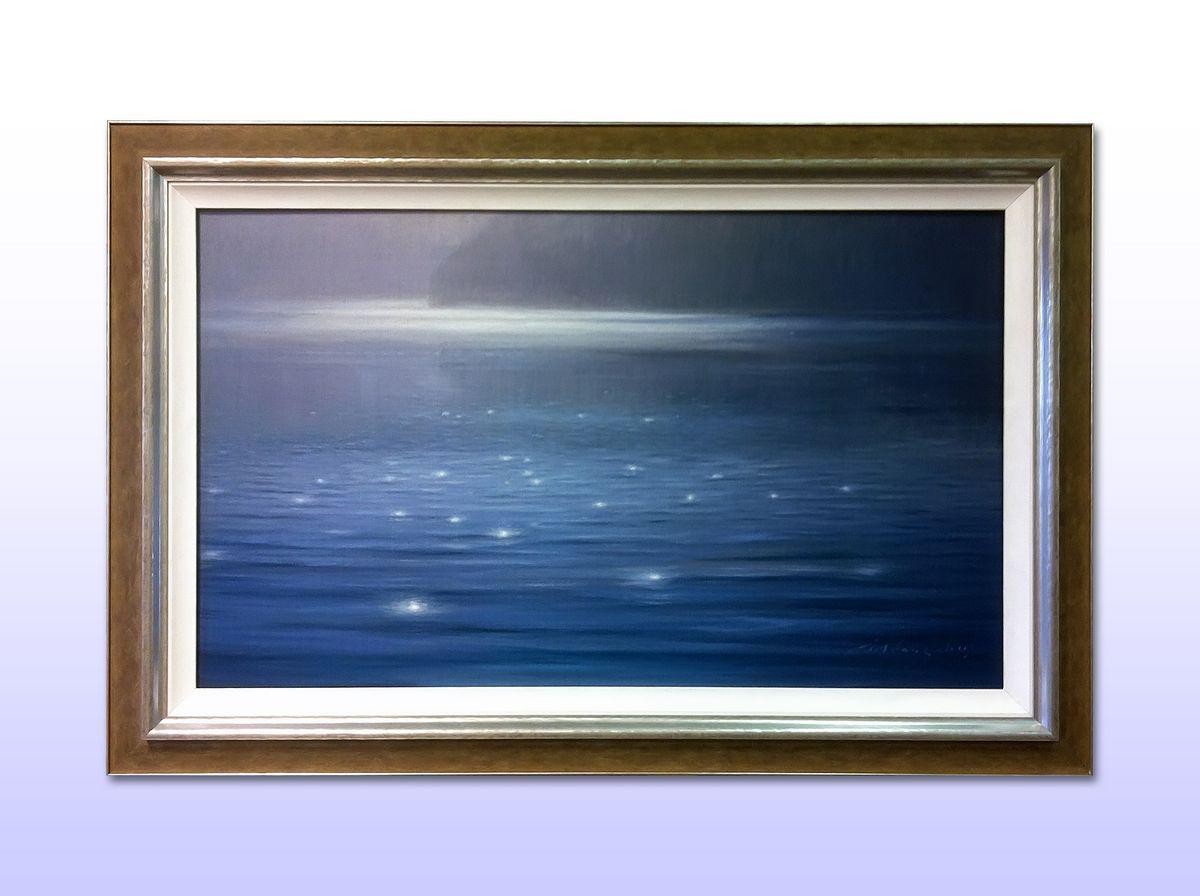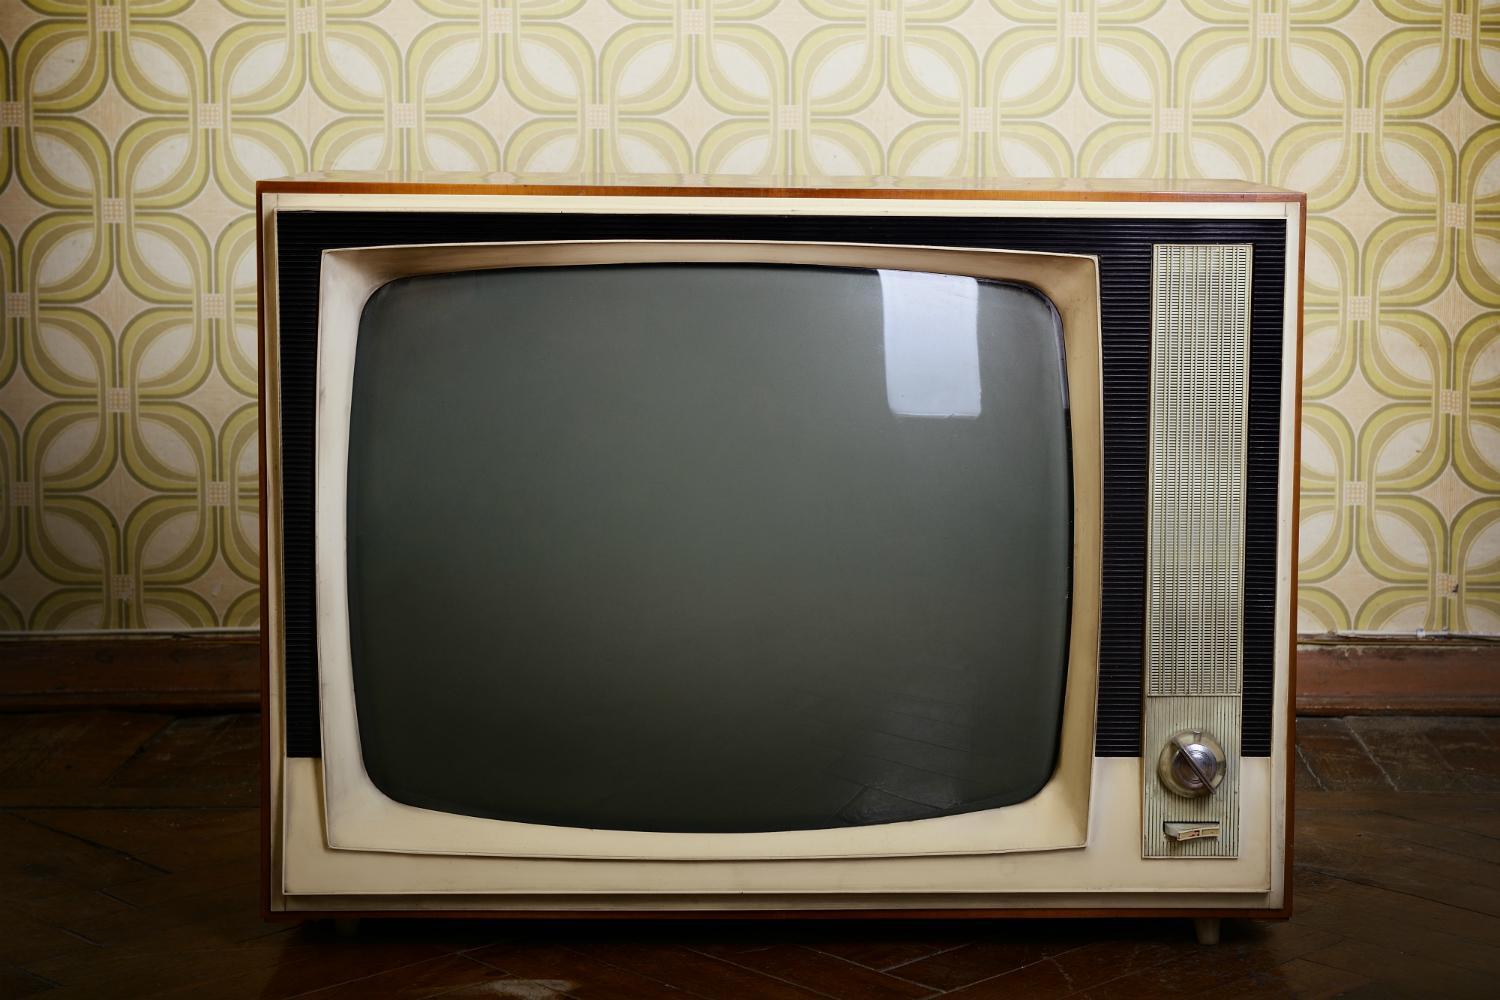The first image is the image on the left, the second image is the image on the right. Considering the images on both sides, is "A portable television has a vertical control area to one side, with two large knobs at the top, and a small speaker area below." valid? Answer yes or no. No. The first image is the image on the left, the second image is the image on the right. Considering the images on both sides, is "A frame is mounted to a wall in the image on the left." valid? Answer yes or no. Yes. 